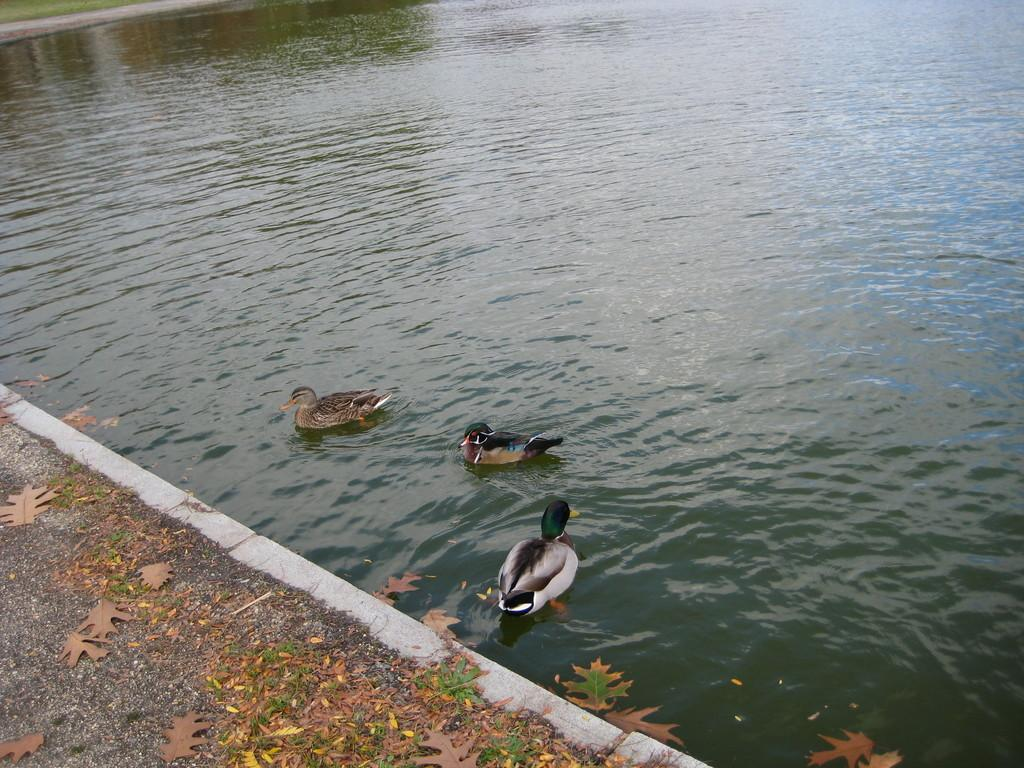What type of animals can be seen in the water in the image? There are ducks in the water in the image. What can be seen on the ground in the image? There are dry leaves on the ground in the image. What sound can be heard coming from the ducks in the image? There is no sound present in the image, as it is a still image. How low are the ducks in the water in the image? The image does not provide information about the depth of the water or the position of the ducks in the water. Can you see any cracks in the leaves on the ground in the image? The image does not show any cracks in the leaves on the ground; it only shows dry leaves. 